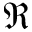<formula> <loc_0><loc_0><loc_500><loc_500>\Re</formula> 